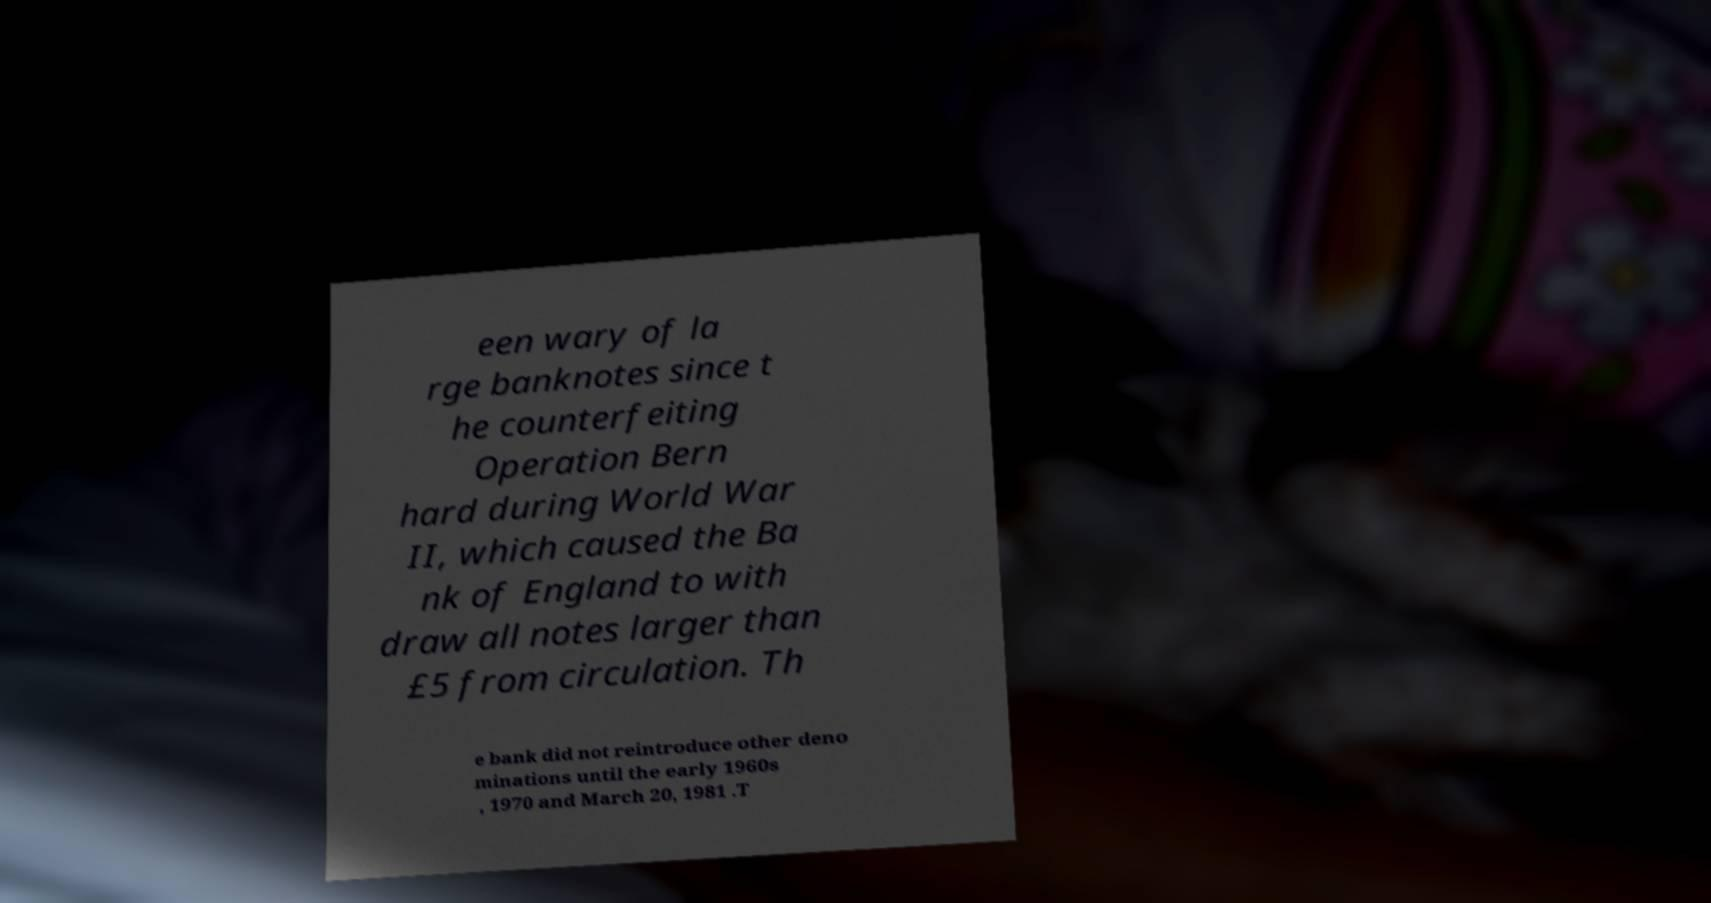For documentation purposes, I need the text within this image transcribed. Could you provide that? een wary of la rge banknotes since t he counterfeiting Operation Bern hard during World War II, which caused the Ba nk of England to with draw all notes larger than £5 from circulation. Th e bank did not reintroduce other deno minations until the early 1960s , 1970 and March 20, 1981 .T 